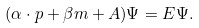Convert formula to latex. <formula><loc_0><loc_0><loc_500><loc_500>( \alpha \cdot p + \beta m + A ) \Psi = E \Psi .</formula> 